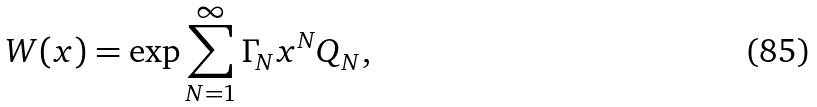Convert formula to latex. <formula><loc_0><loc_0><loc_500><loc_500>W ( x ) = \exp \sum _ { N = 1 } ^ { \infty } \Gamma _ { N } x ^ { N } Q _ { N } ,</formula> 